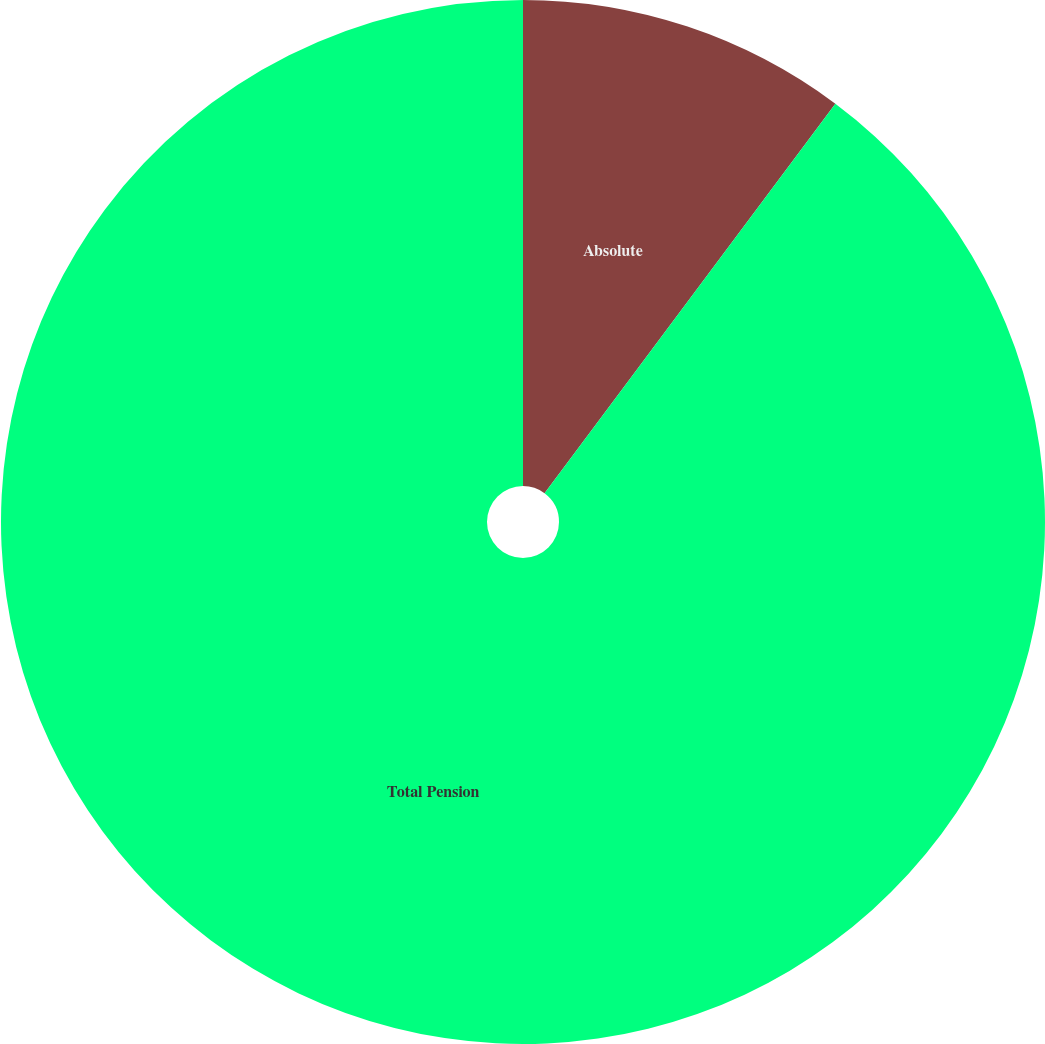Convert chart. <chart><loc_0><loc_0><loc_500><loc_500><pie_chart><fcel>Absolute<fcel>Total Pension<nl><fcel>10.21%<fcel>89.79%<nl></chart> 